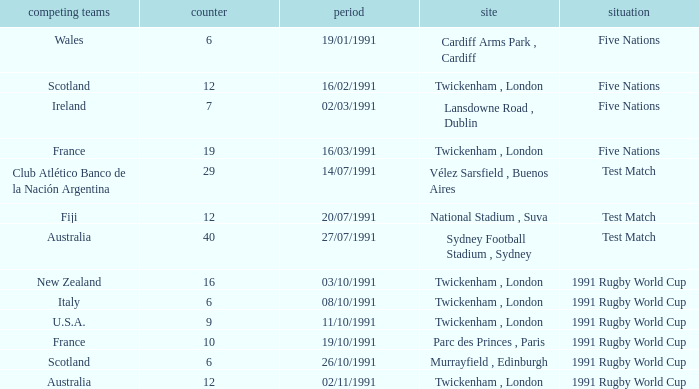What is Date, when Opposing Teams is "Australia", and when Venue is "Twickenham , London"? 02/11/1991. 